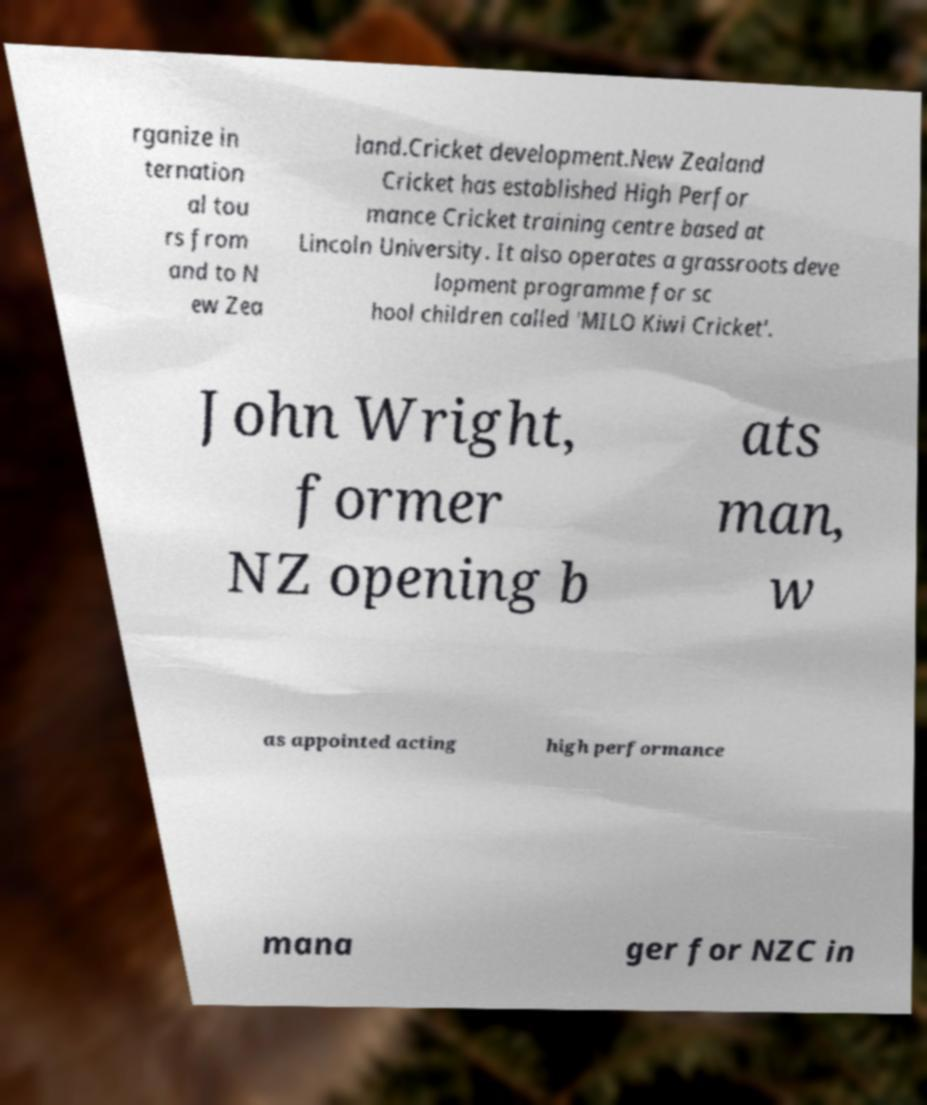Please identify and transcribe the text found in this image. rganize in ternation al tou rs from and to N ew Zea land.Cricket development.New Zealand Cricket has established High Perfor mance Cricket training centre based at Lincoln University. It also operates a grassroots deve lopment programme for sc hool children called 'MILO Kiwi Cricket'. John Wright, former NZ opening b ats man, w as appointed acting high performance mana ger for NZC in 